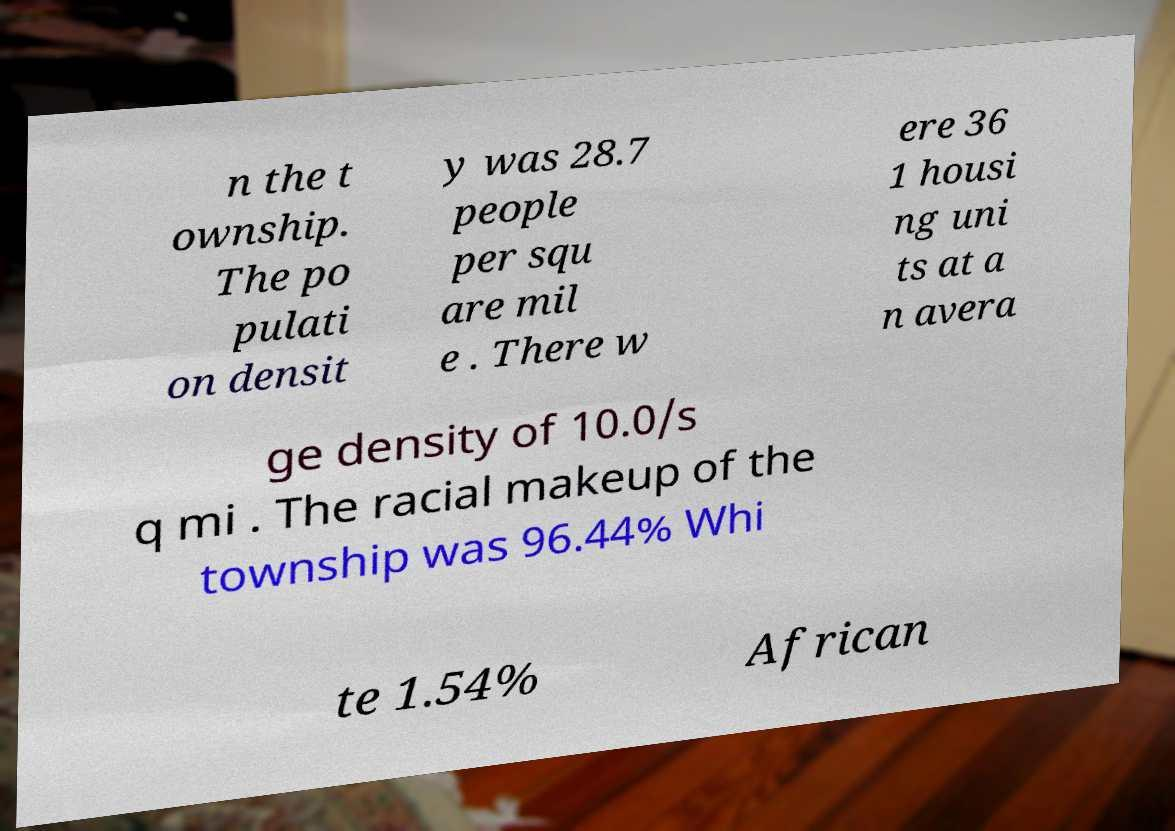What messages or text are displayed in this image? I need them in a readable, typed format. n the t ownship. The po pulati on densit y was 28.7 people per squ are mil e . There w ere 36 1 housi ng uni ts at a n avera ge density of 10.0/s q mi . The racial makeup of the township was 96.44% Whi te 1.54% African 